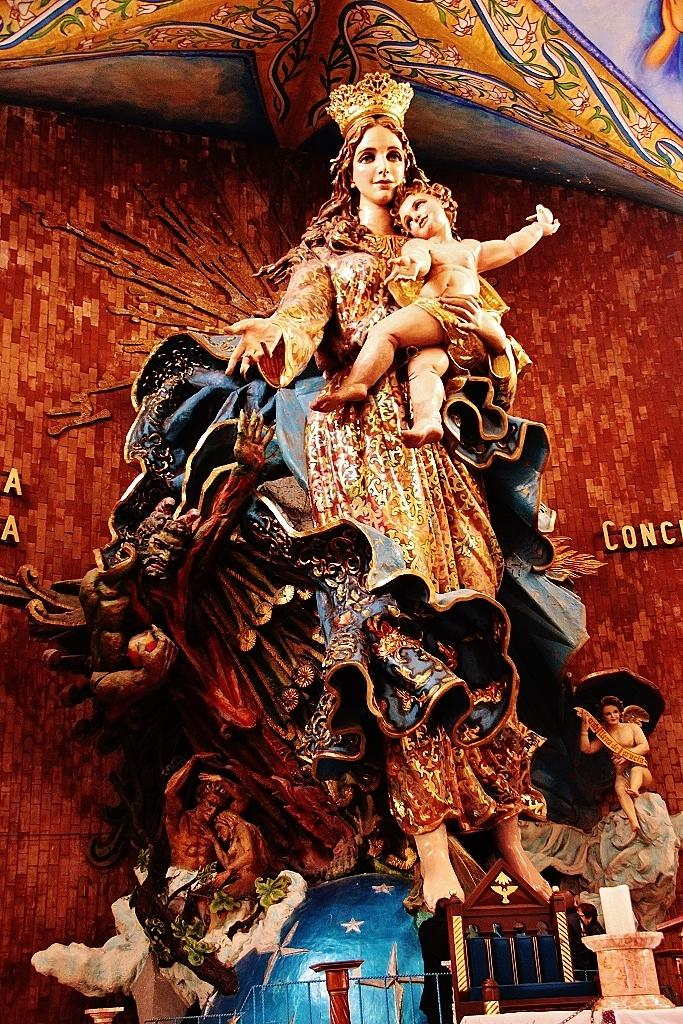What can be seen in the image? There are statues in the image. Where are the statues placed? The statues are kept on a table. What is the subject matter of the statues? The statue depicts a woman holding a boy. Are there any shops visible in the image? No, there are no shops present in the image. Can you see any shock or icicles in the image? No, there is no shock or icicles present in the image. 